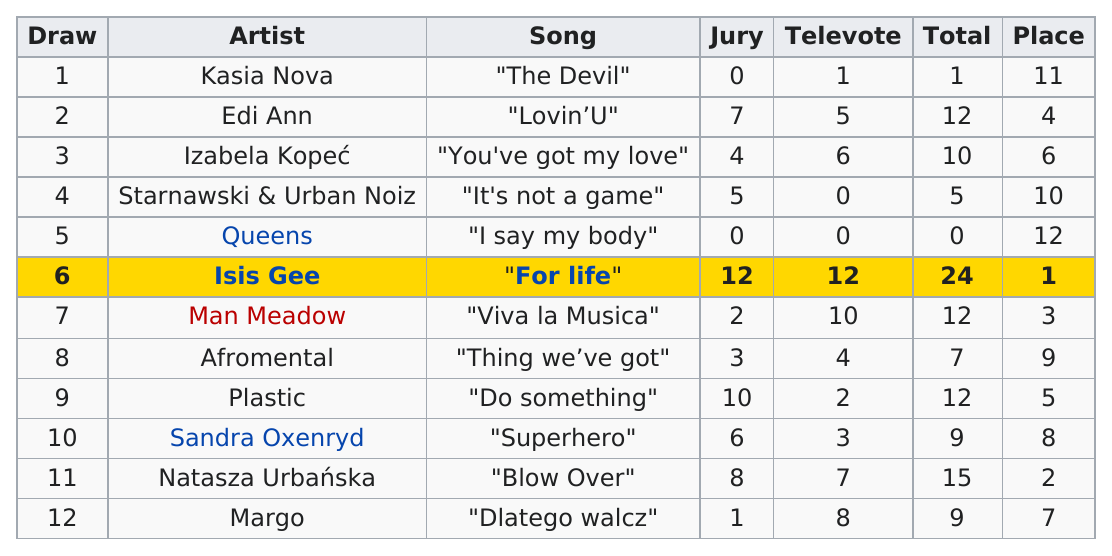Give some essential details in this illustration. Out of the eight songs that were juried, how many were selected? I declare that the song titled 'It's Not a Game' received no televotes. Out of the total number of artists, how many artists received a score of at least 10 points? The answer is 6. The artist who received the same number of jury votes as Kasia Nova is Queen. The first place winner of the Eurovision Song Contest in 2008 was with the song "For Life. 